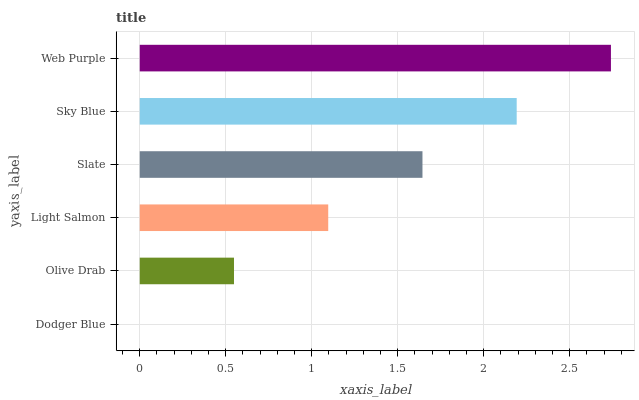Is Dodger Blue the minimum?
Answer yes or no. Yes. Is Web Purple the maximum?
Answer yes or no. Yes. Is Olive Drab the minimum?
Answer yes or no. No. Is Olive Drab the maximum?
Answer yes or no. No. Is Olive Drab greater than Dodger Blue?
Answer yes or no. Yes. Is Dodger Blue less than Olive Drab?
Answer yes or no. Yes. Is Dodger Blue greater than Olive Drab?
Answer yes or no. No. Is Olive Drab less than Dodger Blue?
Answer yes or no. No. Is Slate the high median?
Answer yes or no. Yes. Is Light Salmon the low median?
Answer yes or no. Yes. Is Web Purple the high median?
Answer yes or no. No. Is Sky Blue the low median?
Answer yes or no. No. 